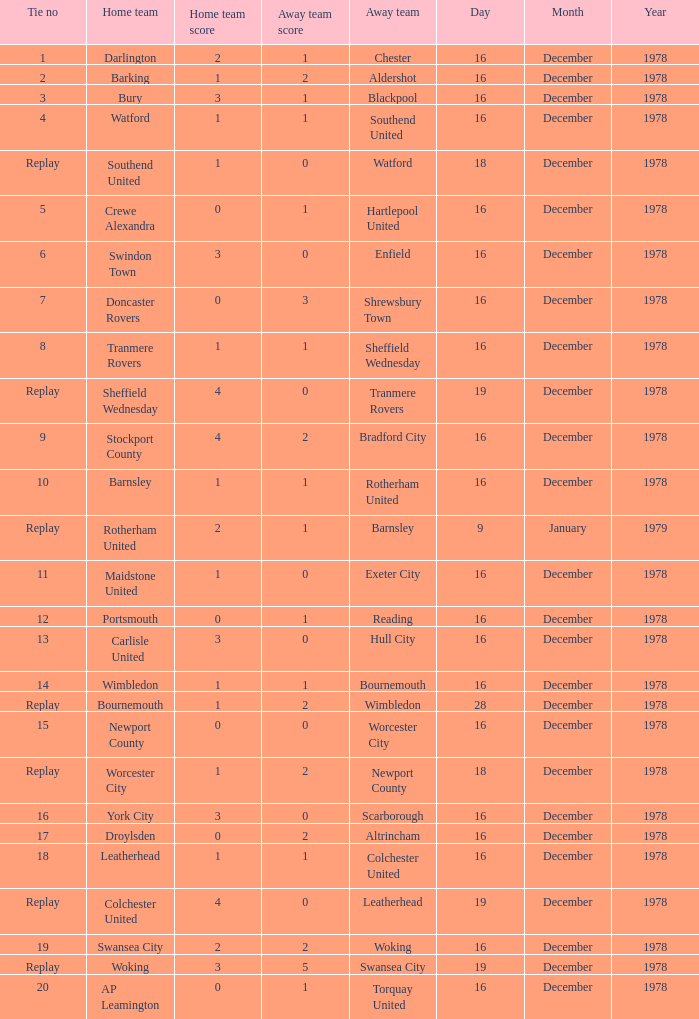What is the tie no for the home team swansea city? 19.0. 